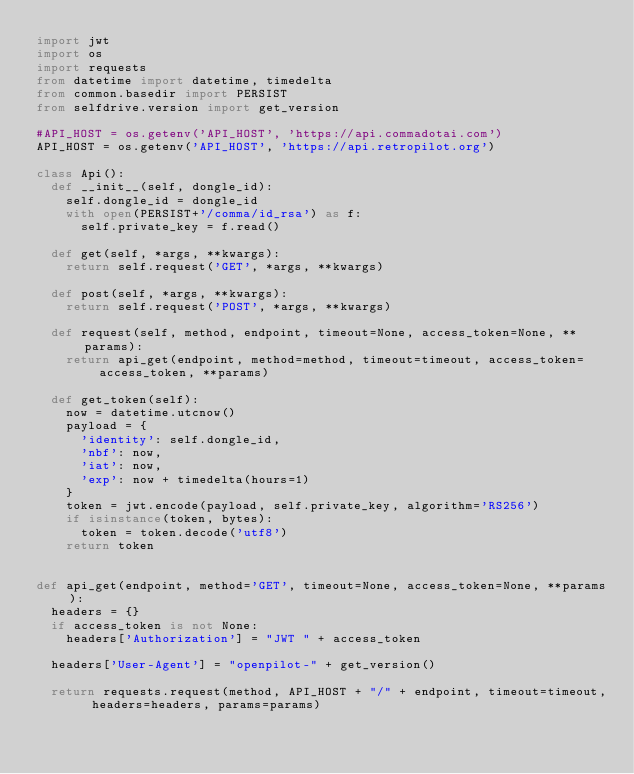<code> <loc_0><loc_0><loc_500><loc_500><_Python_>import jwt
import os
import requests
from datetime import datetime, timedelta
from common.basedir import PERSIST
from selfdrive.version import get_version

#API_HOST = os.getenv('API_HOST', 'https://api.commadotai.com')
API_HOST = os.getenv('API_HOST', 'https://api.retropilot.org')

class Api():
  def __init__(self, dongle_id):
    self.dongle_id = dongle_id
    with open(PERSIST+'/comma/id_rsa') as f:
      self.private_key = f.read()

  def get(self, *args, **kwargs):
    return self.request('GET', *args, **kwargs)

  def post(self, *args, **kwargs):
    return self.request('POST', *args, **kwargs)

  def request(self, method, endpoint, timeout=None, access_token=None, **params):
    return api_get(endpoint, method=method, timeout=timeout, access_token=access_token, **params)

  def get_token(self):
    now = datetime.utcnow()
    payload = {
      'identity': self.dongle_id,
      'nbf': now,
      'iat': now,
      'exp': now + timedelta(hours=1)
    }
    token = jwt.encode(payload, self.private_key, algorithm='RS256')
    if isinstance(token, bytes):
      token = token.decode('utf8')
    return token


def api_get(endpoint, method='GET', timeout=None, access_token=None, **params):
  headers = {}
  if access_token is not None:
    headers['Authorization'] = "JWT " + access_token

  headers['User-Agent'] = "openpilot-" + get_version()

  return requests.request(method, API_HOST + "/" + endpoint, timeout=timeout, headers=headers, params=params)
</code> 